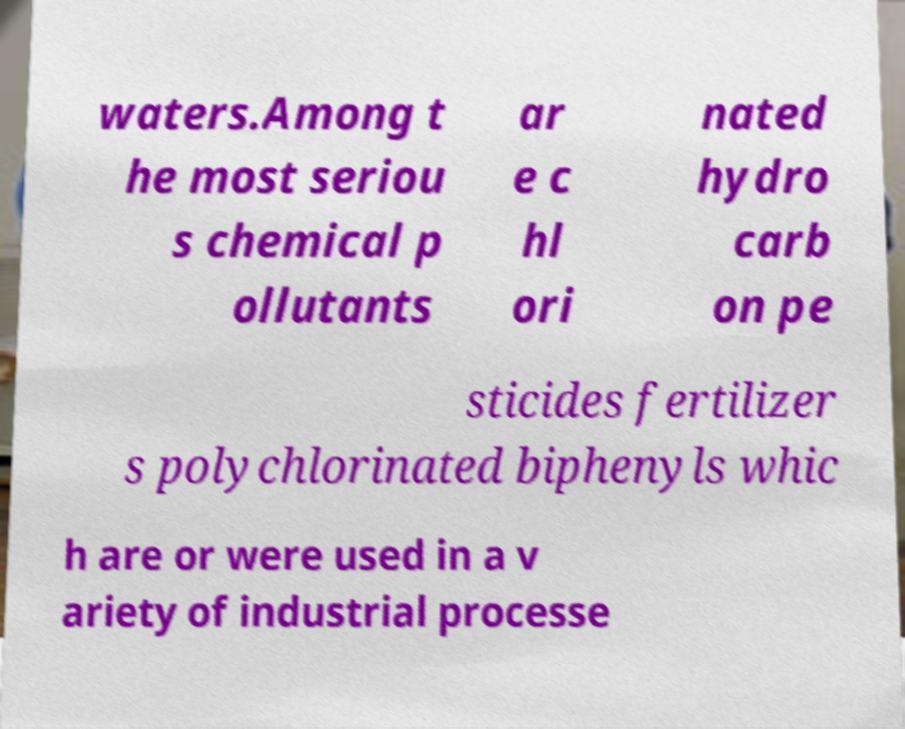Could you extract and type out the text from this image? waters.Among t he most seriou s chemical p ollutants ar e c hl ori nated hydro carb on pe sticides fertilizer s polychlorinated biphenyls whic h are or were used in a v ariety of industrial processe 